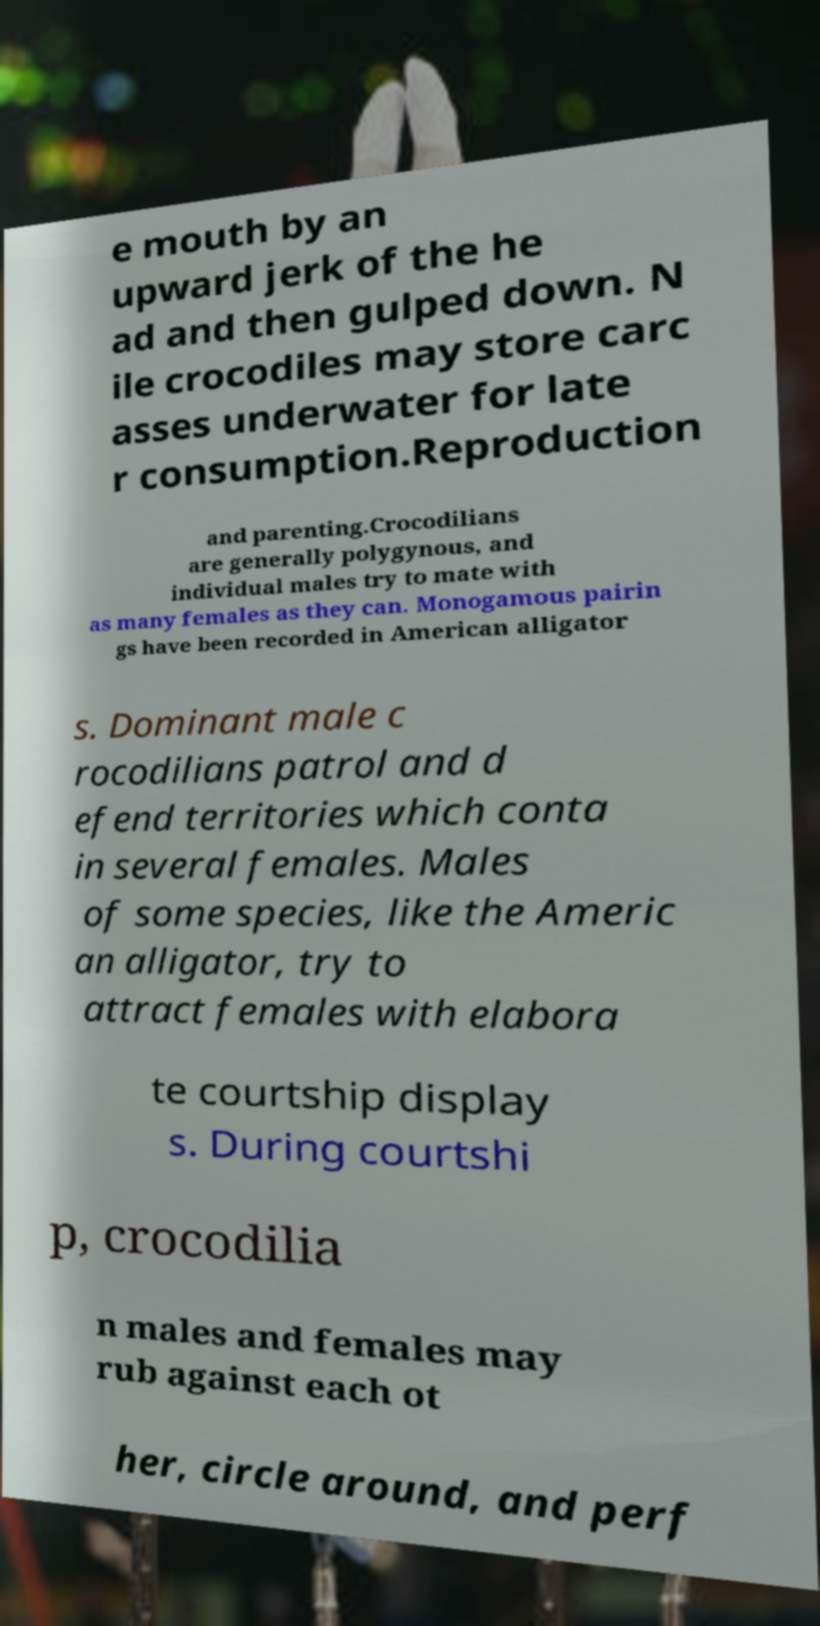Can you read and provide the text displayed in the image?This photo seems to have some interesting text. Can you extract and type it out for me? e mouth by an upward jerk of the he ad and then gulped down. N ile crocodiles may store carc asses underwater for late r consumption.Reproduction and parenting.Crocodilians are generally polygynous, and individual males try to mate with as many females as they can. Monogamous pairin gs have been recorded in American alligator s. Dominant male c rocodilians patrol and d efend territories which conta in several females. Males of some species, like the Americ an alligator, try to attract females with elabora te courtship display s. During courtshi p, crocodilia n males and females may rub against each ot her, circle around, and perf 